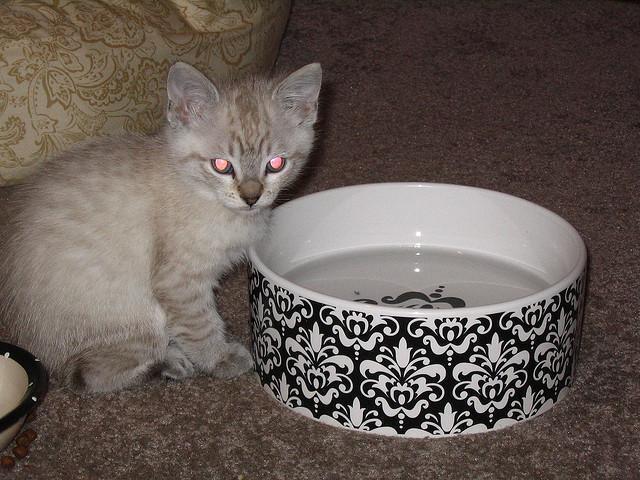How many bowls does the cat have?
Give a very brief answer. 1. How many bowls are there?
Give a very brief answer. 2. 